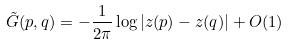<formula> <loc_0><loc_0><loc_500><loc_500>\tilde { G } ( p , q ) = - \frac { 1 } { 2 \pi } \log | z ( p ) - z ( q ) | + O ( 1 )</formula> 